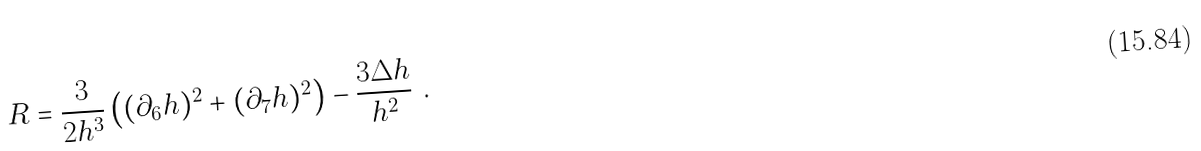<formula> <loc_0><loc_0><loc_500><loc_500>R = \frac { 3 } { 2 h ^ { 3 } } \left ( ( \partial _ { 6 } h ) ^ { 2 } + ( \partial _ { 7 } h ) ^ { 2 } \right ) - \frac { 3 \Delta h } { h ^ { 2 } } \ .</formula> 